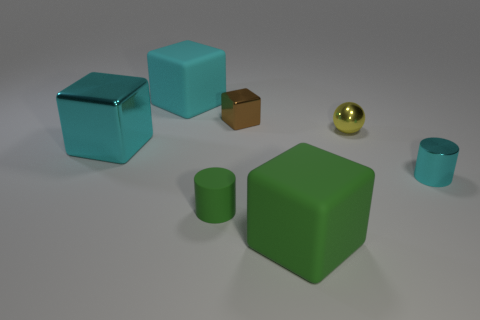Can you tell me the colors of the objects starting from the largest to the smallest? Certainly! Starting from the largest object to the smallest, the colors are green, blue, brown, golden, and teal. 